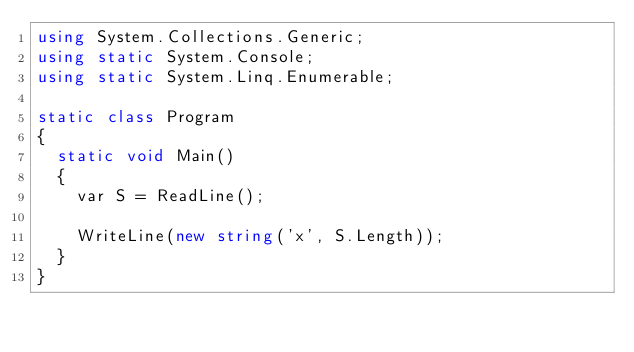<code> <loc_0><loc_0><loc_500><loc_500><_C#_>using System.Collections.Generic;
using static System.Console;
using static System.Linq.Enumerable;

static class Program
{
  static void Main()
  {
    var S = ReadLine();
    
    WriteLine(new string('x', S.Length));
  }
}</code> 